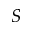<formula> <loc_0><loc_0><loc_500><loc_500>S</formula> 